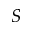<formula> <loc_0><loc_0><loc_500><loc_500>S</formula> 